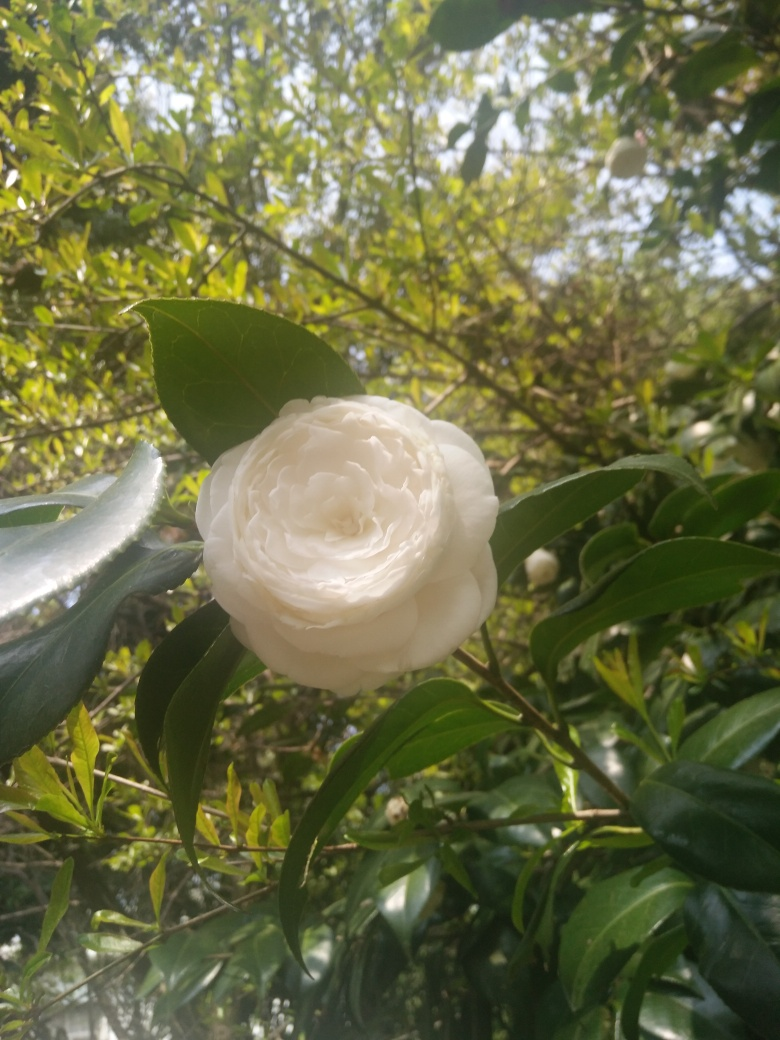How would you describe the flower in the image? The flower appears to be a white camellia with delicate, densely layered petals, presenting a soft and elegant appearance. It's in full bloom, which suggests that the photo was taken at the peak of its flowering season. Can you tell what time of day it might be? Based on the lighting and the shadows in the image, it seems like the photo was taken on a bright day, possibly in the late morning or early afternoon when the sun is higher in the sky, resulting in a soft, diffused light. 